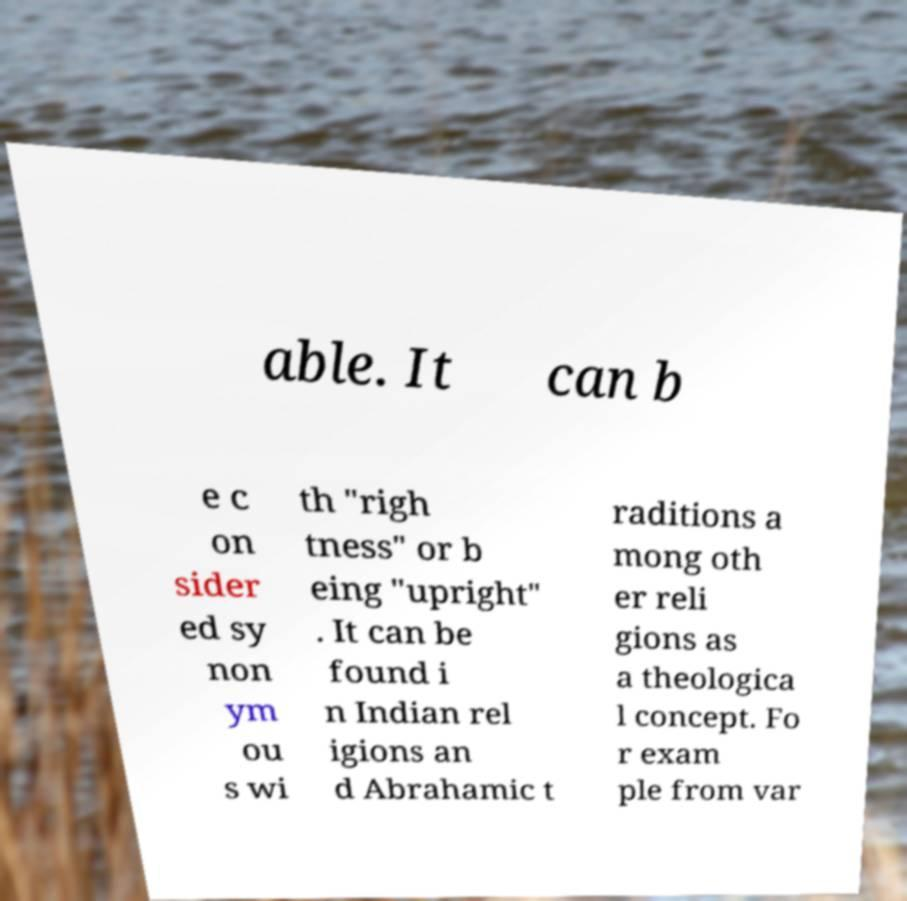I need the written content from this picture converted into text. Can you do that? able. It can b e c on sider ed sy non ym ou s wi th "righ tness" or b eing "upright" . It can be found i n Indian rel igions an d Abrahamic t raditions a mong oth er reli gions as a theologica l concept. Fo r exam ple from var 